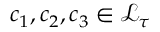Convert formula to latex. <formula><loc_0><loc_0><loc_500><loc_500>c _ { 1 } , c _ { 2 } , c _ { 3 } \in \mathcal { L } _ { \tau }</formula> 